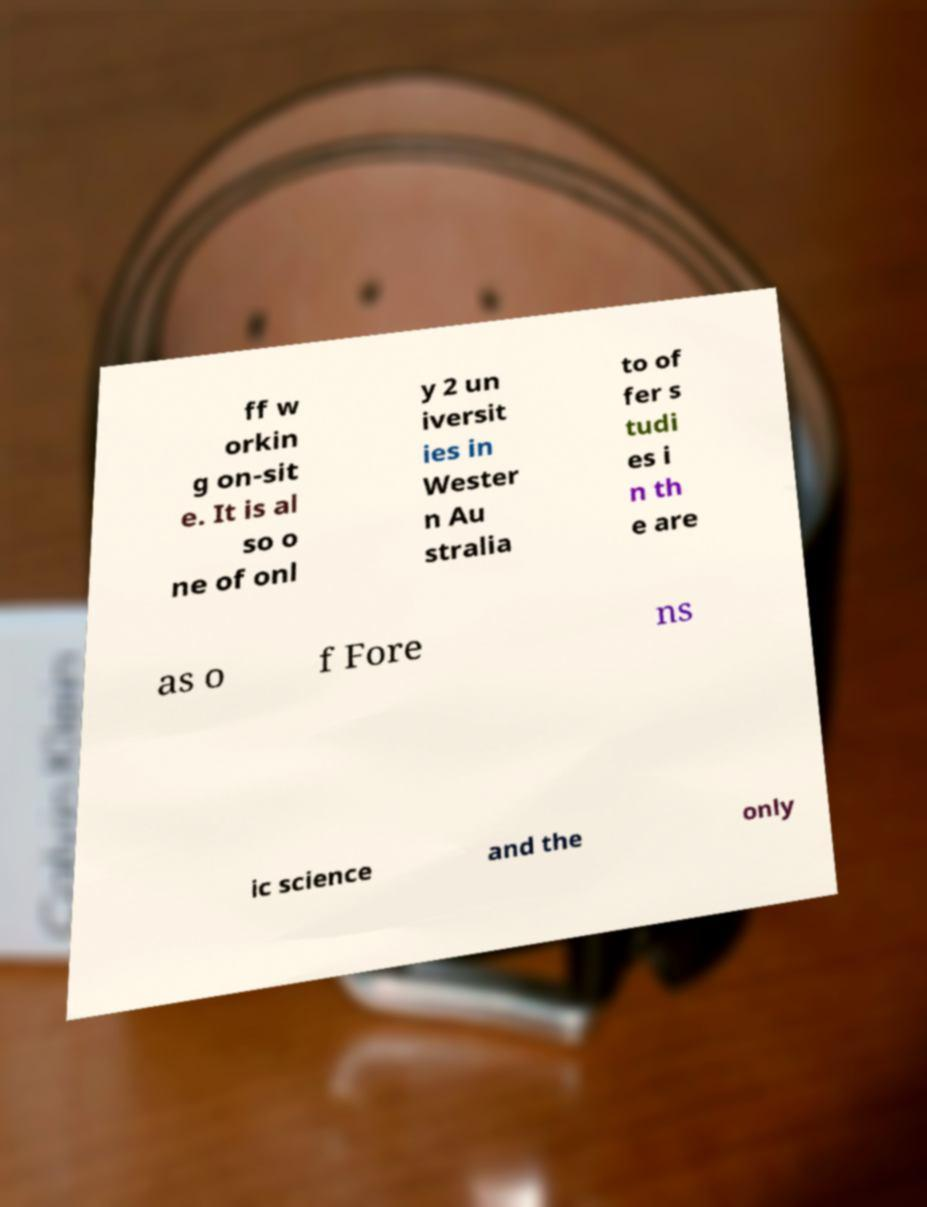Please identify and transcribe the text found in this image. ff w orkin g on-sit e. It is al so o ne of onl y 2 un iversit ies in Wester n Au stralia to of fer s tudi es i n th e are as o f Fore ns ic science and the only 